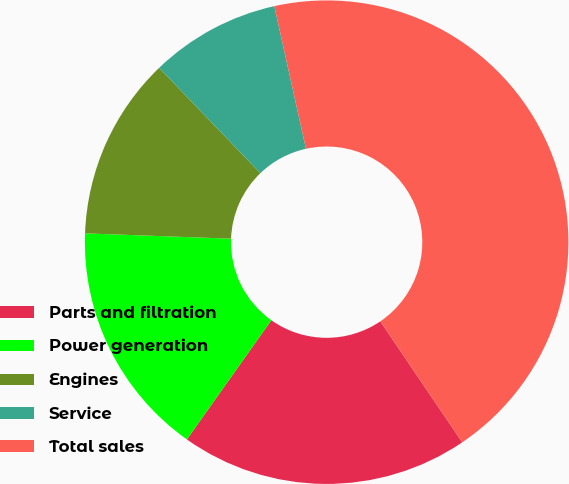Convert chart. <chart><loc_0><loc_0><loc_500><loc_500><pie_chart><fcel>Parts and filtration<fcel>Power generation<fcel>Engines<fcel>Service<fcel>Total sales<nl><fcel>19.29%<fcel>15.77%<fcel>12.24%<fcel>8.71%<fcel>44.0%<nl></chart> 